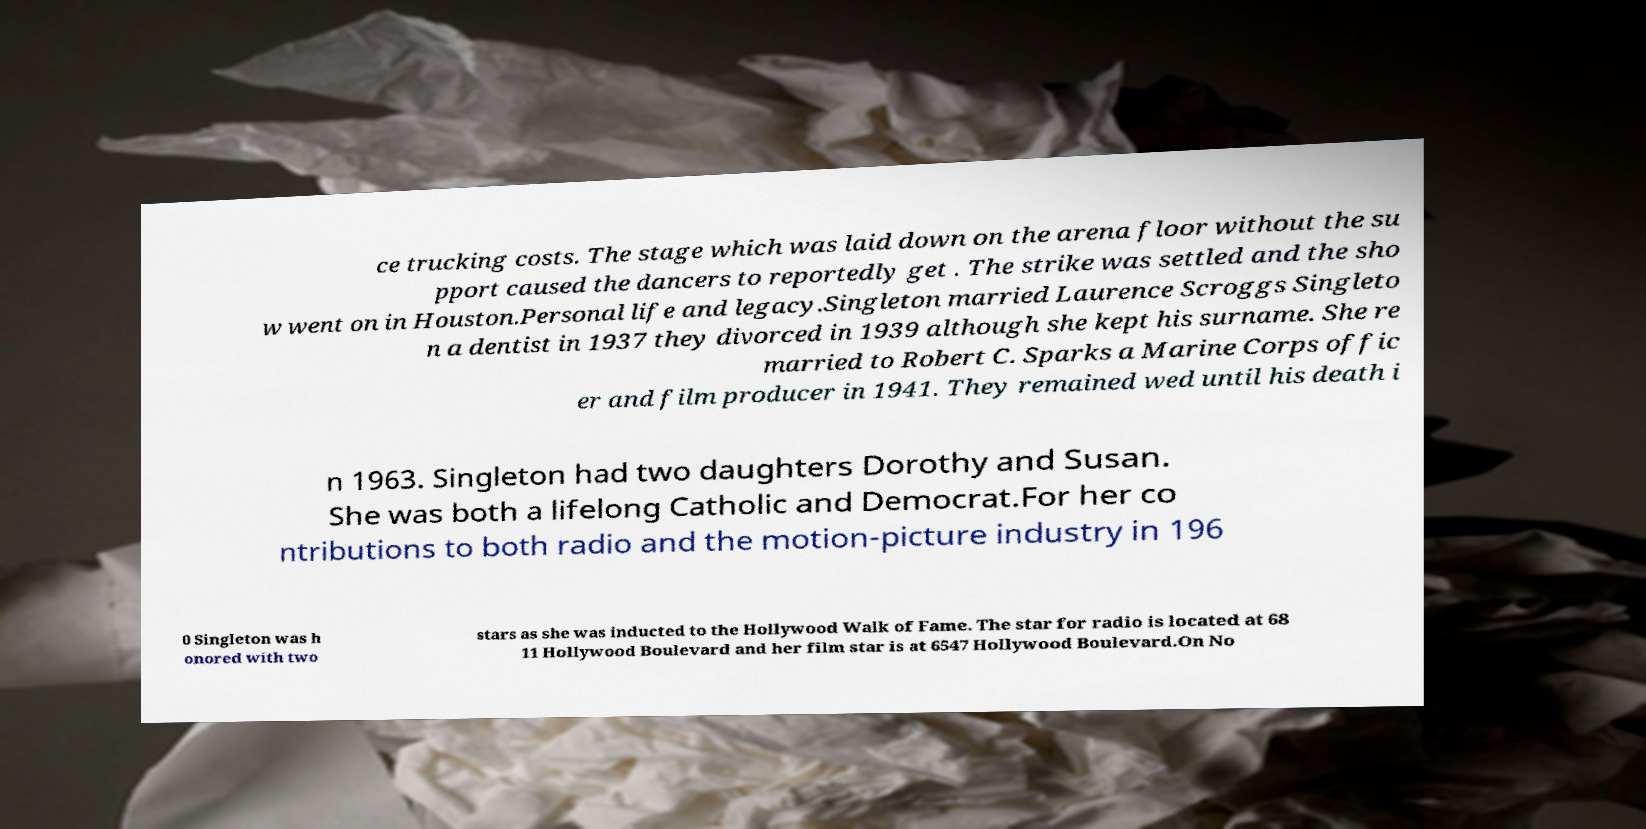I need the written content from this picture converted into text. Can you do that? ce trucking costs. The stage which was laid down on the arena floor without the su pport caused the dancers to reportedly get . The strike was settled and the sho w went on in Houston.Personal life and legacy.Singleton married Laurence Scroggs Singleto n a dentist in 1937 they divorced in 1939 although she kept his surname. She re married to Robert C. Sparks a Marine Corps offic er and film producer in 1941. They remained wed until his death i n 1963. Singleton had two daughters Dorothy and Susan. She was both a lifelong Catholic and Democrat.For her co ntributions to both radio and the motion-picture industry in 196 0 Singleton was h onored with two stars as she was inducted to the Hollywood Walk of Fame. The star for radio is located at 68 11 Hollywood Boulevard and her film star is at 6547 Hollywood Boulevard.On No 